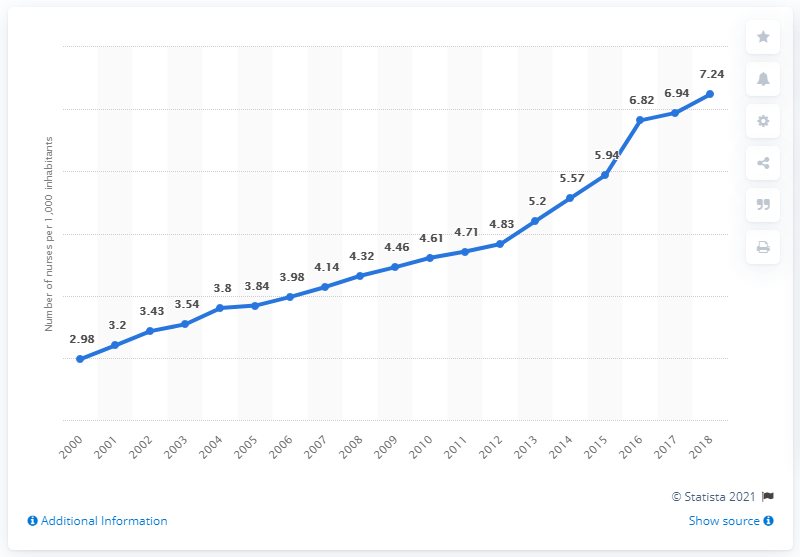List a handful of essential elements in this visual. In 2018, there were approximately 7.24 nurses per 1,000 South Koreans. 